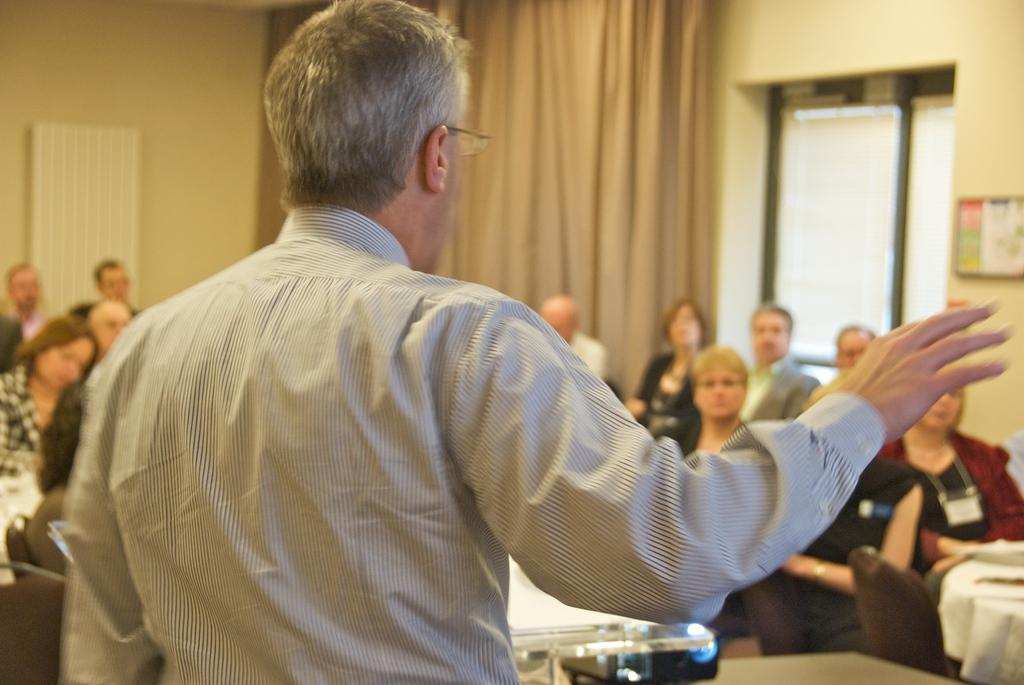What is the main subject of the image? There is a man standing in the image. What is the man wearing? The man is wearing a shirt. What can be seen in the background of the image? There are people sitting, a curtain, a window, and walls visible in the background of the image. How does the beggar push the man in the image? There is no beggar present in the image, and therefore no pushing can be observed. 